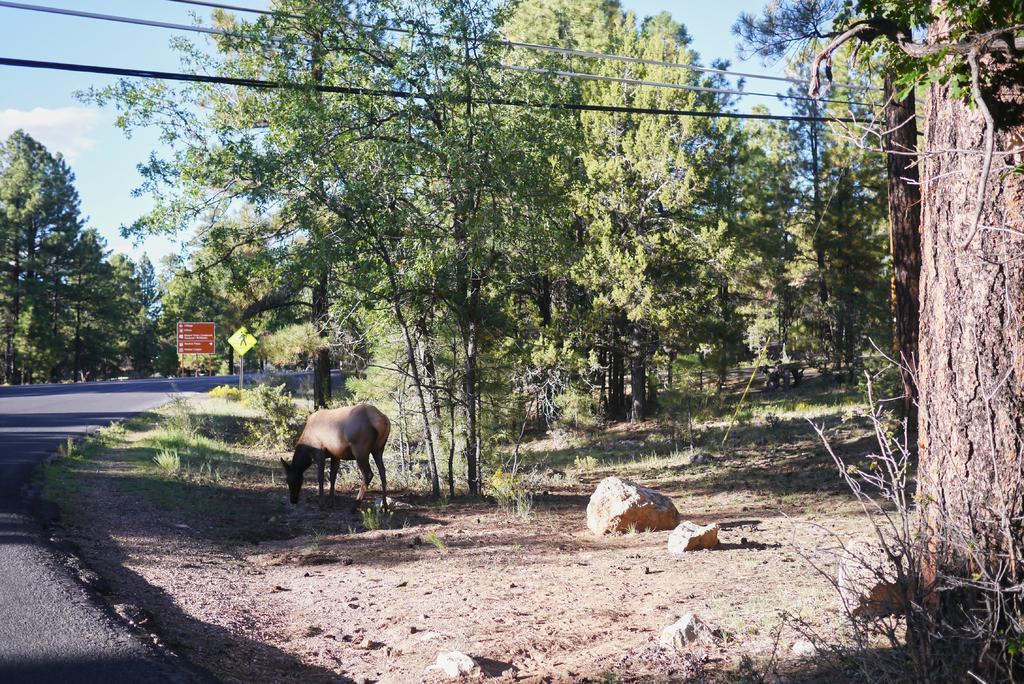Can you describe this image briefly? In this image, I can see an animal. There are rocks, grass, trees, wires and boards. On the left side of the image, I can see the road. In the background, there is the sky. 